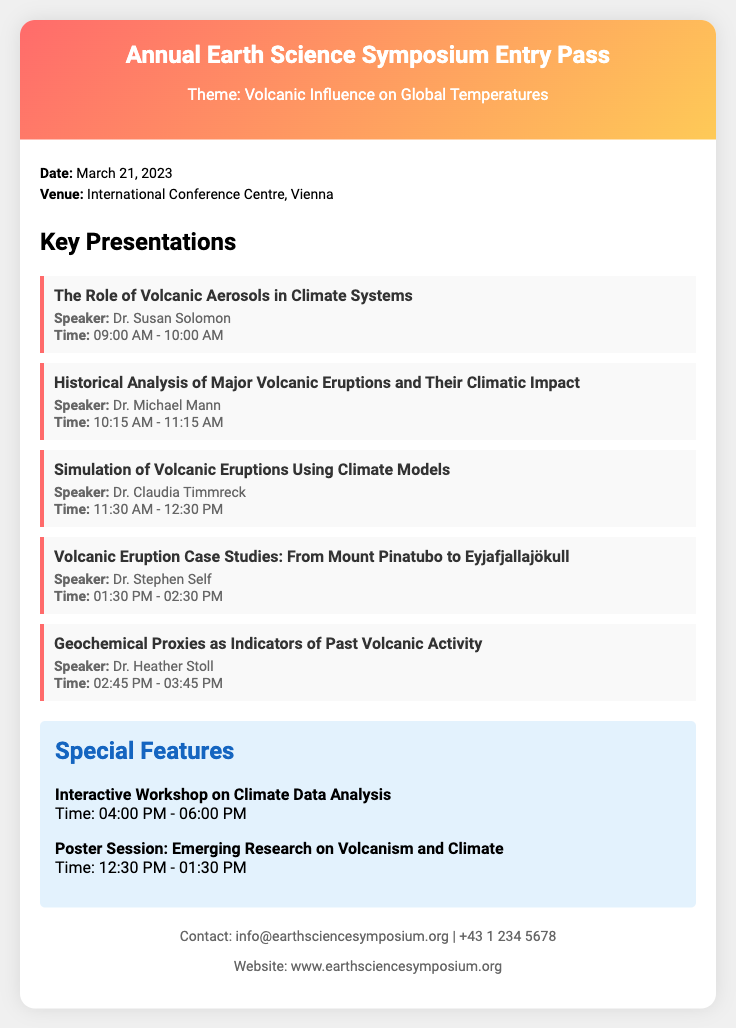What is the date of the symposium? The date is specified in the ticket under the date section.
Answer: March 21, 2023 Where is the symposium being held? The venue is listed in the ticket under the venue section.
Answer: International Conference Centre, Vienna Who is the speaker for the presentation on volcanic aerosols? The speaker's name is mentioned under the key presentations section for that specific topic.
Answer: Dr. Susan Solomon What time does the presentation on historical analysis start? The start time is included in the presentation details.
Answer: 10:15 AM How long is the interactive workshop scheduled for? The duration of the workshop is specified in the special features section.
Answer: 2 hours How many key presentations are listed in the document? The number of presentations can be counted from the key presentations section.
Answer: 5 What is the contact email provided for the symposium? The email is mentioned in the contact section of the ticket.
Answer: info@earthsciencesymposium.org What is one of the special features highlighted in the document? The special features include specific activities listed in that section.
Answer: Interactive Workshop on Climate Data Analysis At what time is the poster session scheduled? The time for the poster session is found in the special features section.
Answer: 12:30 PM - 01:30 PM 